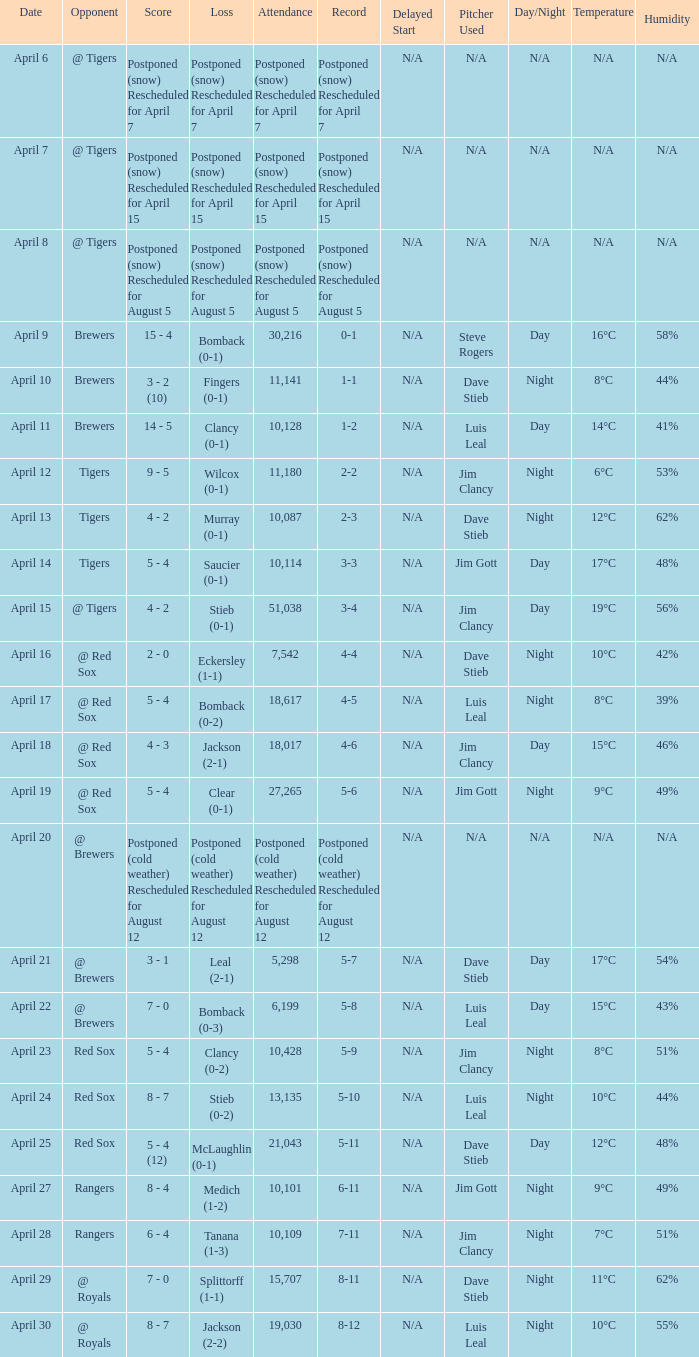What is the score for the game that has an attendance of 5,298? 3 - 1. 